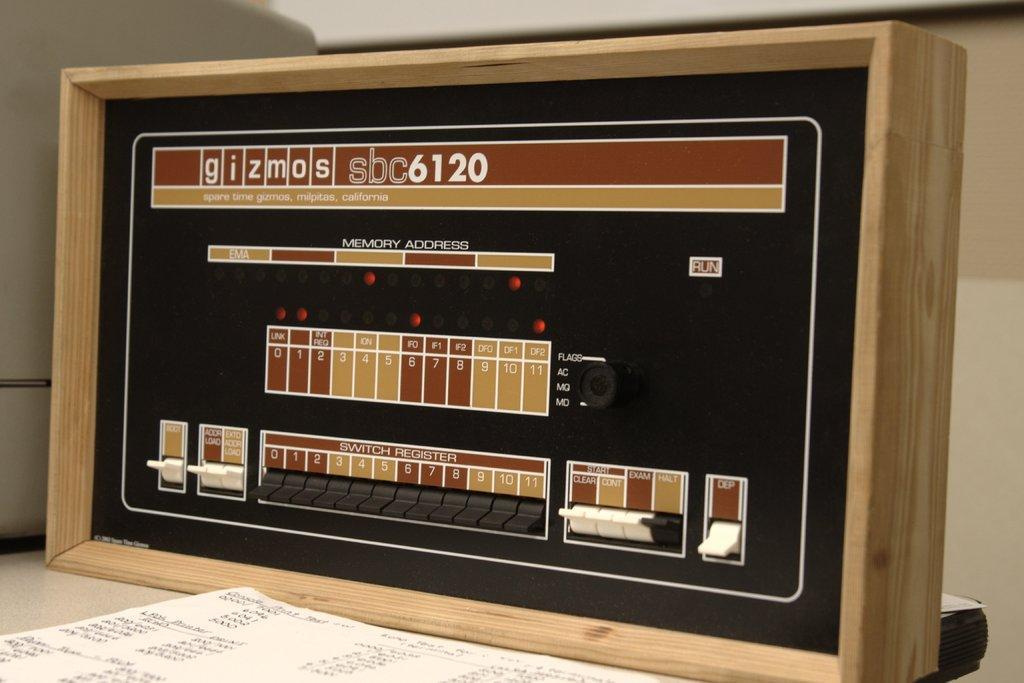Can you describe this image briefly? In this picture we can see an object, paper, device and these all are placed on a platform. 